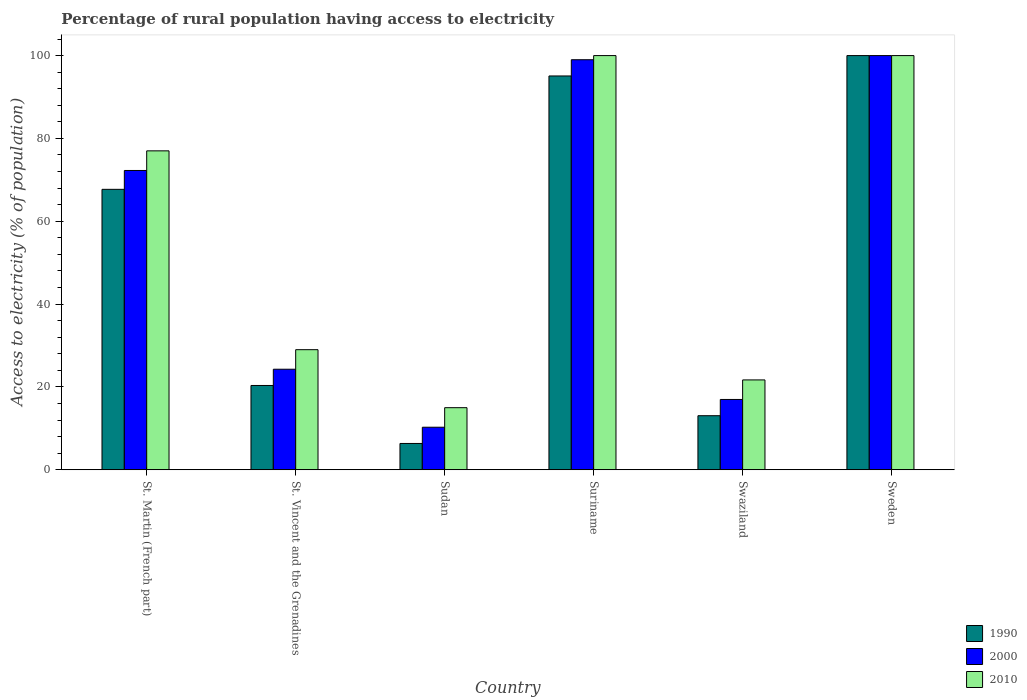Are the number of bars per tick equal to the number of legend labels?
Provide a succinct answer. Yes. Are the number of bars on each tick of the X-axis equal?
Offer a very short reply. Yes. How many bars are there on the 3rd tick from the right?
Ensure brevity in your answer.  3. What is the label of the 3rd group of bars from the left?
Keep it short and to the point. Sudan. In how many cases, is the number of bars for a given country not equal to the number of legend labels?
Keep it short and to the point. 0. What is the percentage of rural population having access to electricity in 1990 in Sudan?
Provide a short and direct response. 6.36. Across all countries, what is the maximum percentage of rural population having access to electricity in 2010?
Provide a succinct answer. 100. Across all countries, what is the minimum percentage of rural population having access to electricity in 2010?
Provide a short and direct response. 15. In which country was the percentage of rural population having access to electricity in 2010 maximum?
Your answer should be very brief. Suriname. In which country was the percentage of rural population having access to electricity in 2000 minimum?
Provide a short and direct response. Sudan. What is the total percentage of rural population having access to electricity in 2010 in the graph?
Provide a short and direct response. 342.7. What is the difference between the percentage of rural population having access to electricity in 1990 in St. Martin (French part) and that in St. Vincent and the Grenadines?
Offer a terse response. 47.35. What is the average percentage of rural population having access to electricity in 2000 per country?
Your answer should be compact. 53.8. What is the difference between the percentage of rural population having access to electricity of/in 1990 and percentage of rural population having access to electricity of/in 2010 in Suriname?
Give a very brief answer. -4.92. What is the ratio of the percentage of rural population having access to electricity in 2000 in St. Vincent and the Grenadines to that in Swaziland?
Your answer should be compact. 1.43. Is the percentage of rural population having access to electricity in 1990 in St. Vincent and the Grenadines less than that in Suriname?
Ensure brevity in your answer.  Yes. Is the difference between the percentage of rural population having access to electricity in 1990 in Suriname and Sweden greater than the difference between the percentage of rural population having access to electricity in 2010 in Suriname and Sweden?
Your response must be concise. No. What is the difference between the highest and the second highest percentage of rural population having access to electricity in 2010?
Provide a succinct answer. 23. What is the difference between the highest and the lowest percentage of rural population having access to electricity in 1990?
Give a very brief answer. 93.64. Is the sum of the percentage of rural population having access to electricity in 1990 in Sudan and Swaziland greater than the maximum percentage of rural population having access to electricity in 2000 across all countries?
Ensure brevity in your answer.  No. What does the 3rd bar from the left in Swaziland represents?
Provide a short and direct response. 2010. What does the 3rd bar from the right in St. Vincent and the Grenadines represents?
Ensure brevity in your answer.  1990. Is it the case that in every country, the sum of the percentage of rural population having access to electricity in 2010 and percentage of rural population having access to electricity in 2000 is greater than the percentage of rural population having access to electricity in 1990?
Give a very brief answer. Yes. Are all the bars in the graph horizontal?
Provide a short and direct response. No. How many countries are there in the graph?
Provide a succinct answer. 6. Are the values on the major ticks of Y-axis written in scientific E-notation?
Offer a very short reply. No. Does the graph contain any zero values?
Give a very brief answer. No. Does the graph contain grids?
Provide a succinct answer. No. Where does the legend appear in the graph?
Provide a short and direct response. Bottom right. What is the title of the graph?
Ensure brevity in your answer.  Percentage of rural population having access to electricity. Does "1989" appear as one of the legend labels in the graph?
Offer a terse response. No. What is the label or title of the Y-axis?
Your answer should be compact. Access to electricity (% of population). What is the Access to electricity (% of population) of 1990 in St. Martin (French part)?
Provide a short and direct response. 67.71. What is the Access to electricity (% of population) in 2000 in St. Martin (French part)?
Offer a very short reply. 72.27. What is the Access to electricity (% of population) in 2010 in St. Martin (French part)?
Make the answer very short. 77. What is the Access to electricity (% of population) of 1990 in St. Vincent and the Grenadines?
Provide a succinct answer. 20.36. What is the Access to electricity (% of population) in 2000 in St. Vincent and the Grenadines?
Keep it short and to the point. 24.28. What is the Access to electricity (% of population) in 2010 in St. Vincent and the Grenadines?
Provide a short and direct response. 29. What is the Access to electricity (% of population) of 1990 in Sudan?
Offer a very short reply. 6.36. What is the Access to electricity (% of population) in 2000 in Sudan?
Give a very brief answer. 10.28. What is the Access to electricity (% of population) of 1990 in Suriname?
Give a very brief answer. 95.08. What is the Access to electricity (% of population) of 2000 in Suriname?
Your response must be concise. 99. What is the Access to electricity (% of population) in 2010 in Suriname?
Provide a succinct answer. 100. What is the Access to electricity (% of population) in 1990 in Swaziland?
Keep it short and to the point. 13.06. What is the Access to electricity (% of population) of 2000 in Swaziland?
Offer a very short reply. 16.98. What is the Access to electricity (% of population) of 2010 in Swaziland?
Provide a succinct answer. 21.7. What is the Access to electricity (% of population) of 1990 in Sweden?
Your answer should be very brief. 100. Across all countries, what is the minimum Access to electricity (% of population) of 1990?
Your answer should be very brief. 6.36. Across all countries, what is the minimum Access to electricity (% of population) in 2000?
Your response must be concise. 10.28. What is the total Access to electricity (% of population) of 1990 in the graph?
Offer a very short reply. 302.57. What is the total Access to electricity (% of population) of 2000 in the graph?
Make the answer very short. 322.81. What is the total Access to electricity (% of population) in 2010 in the graph?
Provide a short and direct response. 342.7. What is the difference between the Access to electricity (% of population) in 1990 in St. Martin (French part) and that in St. Vincent and the Grenadines?
Your answer should be compact. 47.35. What is the difference between the Access to electricity (% of population) of 2000 in St. Martin (French part) and that in St. Vincent and the Grenadines?
Provide a succinct answer. 47.98. What is the difference between the Access to electricity (% of population) in 2010 in St. Martin (French part) and that in St. Vincent and the Grenadines?
Offer a very short reply. 48. What is the difference between the Access to electricity (% of population) in 1990 in St. Martin (French part) and that in Sudan?
Your answer should be compact. 61.35. What is the difference between the Access to electricity (% of population) in 2000 in St. Martin (French part) and that in Sudan?
Offer a very short reply. 61.98. What is the difference between the Access to electricity (% of population) in 1990 in St. Martin (French part) and that in Suriname?
Offer a very short reply. -27.37. What is the difference between the Access to electricity (% of population) in 2000 in St. Martin (French part) and that in Suriname?
Make the answer very short. -26.73. What is the difference between the Access to electricity (% of population) of 2010 in St. Martin (French part) and that in Suriname?
Provide a short and direct response. -23. What is the difference between the Access to electricity (% of population) in 1990 in St. Martin (French part) and that in Swaziland?
Provide a short and direct response. 54.65. What is the difference between the Access to electricity (% of population) in 2000 in St. Martin (French part) and that in Swaziland?
Make the answer very short. 55.28. What is the difference between the Access to electricity (% of population) in 2010 in St. Martin (French part) and that in Swaziland?
Give a very brief answer. 55.3. What is the difference between the Access to electricity (% of population) in 1990 in St. Martin (French part) and that in Sweden?
Make the answer very short. -32.29. What is the difference between the Access to electricity (% of population) in 2000 in St. Martin (French part) and that in Sweden?
Offer a very short reply. -27.73. What is the difference between the Access to electricity (% of population) of 2000 in St. Vincent and the Grenadines and that in Sudan?
Your answer should be very brief. 14. What is the difference between the Access to electricity (% of population) of 2010 in St. Vincent and the Grenadines and that in Sudan?
Keep it short and to the point. 14. What is the difference between the Access to electricity (% of population) in 1990 in St. Vincent and the Grenadines and that in Suriname?
Make the answer very short. -74.72. What is the difference between the Access to electricity (% of population) in 2000 in St. Vincent and the Grenadines and that in Suriname?
Provide a short and direct response. -74.72. What is the difference between the Access to electricity (% of population) in 2010 in St. Vincent and the Grenadines and that in Suriname?
Provide a short and direct response. -71. What is the difference between the Access to electricity (% of population) of 1990 in St. Vincent and the Grenadines and that in Swaziland?
Provide a short and direct response. 7.3. What is the difference between the Access to electricity (% of population) of 2000 in St. Vincent and the Grenadines and that in Swaziland?
Provide a short and direct response. 7.3. What is the difference between the Access to electricity (% of population) of 2010 in St. Vincent and the Grenadines and that in Swaziland?
Your answer should be very brief. 7.3. What is the difference between the Access to electricity (% of population) in 1990 in St. Vincent and the Grenadines and that in Sweden?
Your answer should be very brief. -79.64. What is the difference between the Access to electricity (% of population) of 2000 in St. Vincent and the Grenadines and that in Sweden?
Your response must be concise. -75.72. What is the difference between the Access to electricity (% of population) in 2010 in St. Vincent and the Grenadines and that in Sweden?
Make the answer very short. -71. What is the difference between the Access to electricity (% of population) of 1990 in Sudan and that in Suriname?
Make the answer very short. -88.72. What is the difference between the Access to electricity (% of population) in 2000 in Sudan and that in Suriname?
Provide a short and direct response. -88.72. What is the difference between the Access to electricity (% of population) of 2010 in Sudan and that in Suriname?
Your answer should be compact. -85. What is the difference between the Access to electricity (% of population) in 1990 in Sudan and that in Swaziland?
Ensure brevity in your answer.  -6.7. What is the difference between the Access to electricity (% of population) in 1990 in Sudan and that in Sweden?
Your answer should be very brief. -93.64. What is the difference between the Access to electricity (% of population) in 2000 in Sudan and that in Sweden?
Offer a very short reply. -89.72. What is the difference between the Access to electricity (% of population) in 2010 in Sudan and that in Sweden?
Make the answer very short. -85. What is the difference between the Access to electricity (% of population) in 1990 in Suriname and that in Swaziland?
Offer a terse response. 82.02. What is the difference between the Access to electricity (% of population) in 2000 in Suriname and that in Swaziland?
Give a very brief answer. 82.02. What is the difference between the Access to electricity (% of population) in 2010 in Suriname and that in Swaziland?
Offer a terse response. 78.3. What is the difference between the Access to electricity (% of population) of 1990 in Suriname and that in Sweden?
Make the answer very short. -4.92. What is the difference between the Access to electricity (% of population) of 1990 in Swaziland and that in Sweden?
Your answer should be very brief. -86.94. What is the difference between the Access to electricity (% of population) in 2000 in Swaziland and that in Sweden?
Provide a short and direct response. -83.02. What is the difference between the Access to electricity (% of population) of 2010 in Swaziland and that in Sweden?
Make the answer very short. -78.3. What is the difference between the Access to electricity (% of population) of 1990 in St. Martin (French part) and the Access to electricity (% of population) of 2000 in St. Vincent and the Grenadines?
Offer a very short reply. 43.43. What is the difference between the Access to electricity (% of population) of 1990 in St. Martin (French part) and the Access to electricity (% of population) of 2010 in St. Vincent and the Grenadines?
Keep it short and to the point. 38.71. What is the difference between the Access to electricity (% of population) of 2000 in St. Martin (French part) and the Access to electricity (% of population) of 2010 in St. Vincent and the Grenadines?
Your answer should be very brief. 43.27. What is the difference between the Access to electricity (% of population) of 1990 in St. Martin (French part) and the Access to electricity (% of population) of 2000 in Sudan?
Your answer should be very brief. 57.43. What is the difference between the Access to electricity (% of population) in 1990 in St. Martin (French part) and the Access to electricity (% of population) in 2010 in Sudan?
Keep it short and to the point. 52.71. What is the difference between the Access to electricity (% of population) in 2000 in St. Martin (French part) and the Access to electricity (% of population) in 2010 in Sudan?
Make the answer very short. 57.27. What is the difference between the Access to electricity (% of population) of 1990 in St. Martin (French part) and the Access to electricity (% of population) of 2000 in Suriname?
Provide a succinct answer. -31.29. What is the difference between the Access to electricity (% of population) in 1990 in St. Martin (French part) and the Access to electricity (% of population) in 2010 in Suriname?
Provide a short and direct response. -32.29. What is the difference between the Access to electricity (% of population) of 2000 in St. Martin (French part) and the Access to electricity (% of population) of 2010 in Suriname?
Your answer should be very brief. -27.73. What is the difference between the Access to electricity (% of population) of 1990 in St. Martin (French part) and the Access to electricity (% of population) of 2000 in Swaziland?
Make the answer very short. 50.73. What is the difference between the Access to electricity (% of population) in 1990 in St. Martin (French part) and the Access to electricity (% of population) in 2010 in Swaziland?
Provide a succinct answer. 46.01. What is the difference between the Access to electricity (% of population) of 2000 in St. Martin (French part) and the Access to electricity (% of population) of 2010 in Swaziland?
Your answer should be very brief. 50.56. What is the difference between the Access to electricity (% of population) of 1990 in St. Martin (French part) and the Access to electricity (% of population) of 2000 in Sweden?
Provide a succinct answer. -32.29. What is the difference between the Access to electricity (% of population) in 1990 in St. Martin (French part) and the Access to electricity (% of population) in 2010 in Sweden?
Provide a succinct answer. -32.29. What is the difference between the Access to electricity (% of population) in 2000 in St. Martin (French part) and the Access to electricity (% of population) in 2010 in Sweden?
Your answer should be very brief. -27.73. What is the difference between the Access to electricity (% of population) of 1990 in St. Vincent and the Grenadines and the Access to electricity (% of population) of 2000 in Sudan?
Provide a succinct answer. 10.08. What is the difference between the Access to electricity (% of population) of 1990 in St. Vincent and the Grenadines and the Access to electricity (% of population) of 2010 in Sudan?
Give a very brief answer. 5.36. What is the difference between the Access to electricity (% of population) in 2000 in St. Vincent and the Grenadines and the Access to electricity (% of population) in 2010 in Sudan?
Your answer should be very brief. 9.28. What is the difference between the Access to electricity (% of population) in 1990 in St. Vincent and the Grenadines and the Access to electricity (% of population) in 2000 in Suriname?
Give a very brief answer. -78.64. What is the difference between the Access to electricity (% of population) in 1990 in St. Vincent and the Grenadines and the Access to electricity (% of population) in 2010 in Suriname?
Offer a terse response. -79.64. What is the difference between the Access to electricity (% of population) in 2000 in St. Vincent and the Grenadines and the Access to electricity (% of population) in 2010 in Suriname?
Offer a very short reply. -75.72. What is the difference between the Access to electricity (% of population) in 1990 in St. Vincent and the Grenadines and the Access to electricity (% of population) in 2000 in Swaziland?
Make the answer very short. 3.38. What is the difference between the Access to electricity (% of population) in 1990 in St. Vincent and the Grenadines and the Access to electricity (% of population) in 2010 in Swaziland?
Your answer should be compact. -1.34. What is the difference between the Access to electricity (% of population) of 2000 in St. Vincent and the Grenadines and the Access to electricity (% of population) of 2010 in Swaziland?
Your answer should be very brief. 2.58. What is the difference between the Access to electricity (% of population) of 1990 in St. Vincent and the Grenadines and the Access to electricity (% of population) of 2000 in Sweden?
Ensure brevity in your answer.  -79.64. What is the difference between the Access to electricity (% of population) of 1990 in St. Vincent and the Grenadines and the Access to electricity (% of population) of 2010 in Sweden?
Keep it short and to the point. -79.64. What is the difference between the Access to electricity (% of population) in 2000 in St. Vincent and the Grenadines and the Access to electricity (% of population) in 2010 in Sweden?
Keep it short and to the point. -75.72. What is the difference between the Access to electricity (% of population) in 1990 in Sudan and the Access to electricity (% of population) in 2000 in Suriname?
Offer a terse response. -92.64. What is the difference between the Access to electricity (% of population) of 1990 in Sudan and the Access to electricity (% of population) of 2010 in Suriname?
Keep it short and to the point. -93.64. What is the difference between the Access to electricity (% of population) in 2000 in Sudan and the Access to electricity (% of population) in 2010 in Suriname?
Provide a short and direct response. -89.72. What is the difference between the Access to electricity (% of population) in 1990 in Sudan and the Access to electricity (% of population) in 2000 in Swaziland?
Your answer should be very brief. -10.62. What is the difference between the Access to electricity (% of population) in 1990 in Sudan and the Access to electricity (% of population) in 2010 in Swaziland?
Provide a succinct answer. -15.34. What is the difference between the Access to electricity (% of population) of 2000 in Sudan and the Access to electricity (% of population) of 2010 in Swaziland?
Keep it short and to the point. -11.42. What is the difference between the Access to electricity (% of population) of 1990 in Sudan and the Access to electricity (% of population) of 2000 in Sweden?
Your response must be concise. -93.64. What is the difference between the Access to electricity (% of population) of 1990 in Sudan and the Access to electricity (% of population) of 2010 in Sweden?
Your response must be concise. -93.64. What is the difference between the Access to electricity (% of population) of 2000 in Sudan and the Access to electricity (% of population) of 2010 in Sweden?
Your response must be concise. -89.72. What is the difference between the Access to electricity (% of population) in 1990 in Suriname and the Access to electricity (% of population) in 2000 in Swaziland?
Give a very brief answer. 78.1. What is the difference between the Access to electricity (% of population) of 1990 in Suriname and the Access to electricity (% of population) of 2010 in Swaziland?
Make the answer very short. 73.38. What is the difference between the Access to electricity (% of population) in 2000 in Suriname and the Access to electricity (% of population) in 2010 in Swaziland?
Make the answer very short. 77.3. What is the difference between the Access to electricity (% of population) of 1990 in Suriname and the Access to electricity (% of population) of 2000 in Sweden?
Your response must be concise. -4.92. What is the difference between the Access to electricity (% of population) of 1990 in Suriname and the Access to electricity (% of population) of 2010 in Sweden?
Your response must be concise. -4.92. What is the difference between the Access to electricity (% of population) of 2000 in Suriname and the Access to electricity (% of population) of 2010 in Sweden?
Offer a terse response. -1. What is the difference between the Access to electricity (% of population) of 1990 in Swaziland and the Access to electricity (% of population) of 2000 in Sweden?
Provide a short and direct response. -86.94. What is the difference between the Access to electricity (% of population) of 1990 in Swaziland and the Access to electricity (% of population) of 2010 in Sweden?
Keep it short and to the point. -86.94. What is the difference between the Access to electricity (% of population) in 2000 in Swaziland and the Access to electricity (% of population) in 2010 in Sweden?
Ensure brevity in your answer.  -83.02. What is the average Access to electricity (% of population) of 1990 per country?
Give a very brief answer. 50.43. What is the average Access to electricity (% of population) in 2000 per country?
Give a very brief answer. 53.8. What is the average Access to electricity (% of population) in 2010 per country?
Your response must be concise. 57.12. What is the difference between the Access to electricity (% of population) of 1990 and Access to electricity (% of population) of 2000 in St. Martin (French part)?
Your answer should be compact. -4.55. What is the difference between the Access to electricity (% of population) of 1990 and Access to electricity (% of population) of 2010 in St. Martin (French part)?
Give a very brief answer. -9.29. What is the difference between the Access to electricity (% of population) of 2000 and Access to electricity (% of population) of 2010 in St. Martin (French part)?
Provide a short and direct response. -4.74. What is the difference between the Access to electricity (% of population) in 1990 and Access to electricity (% of population) in 2000 in St. Vincent and the Grenadines?
Ensure brevity in your answer.  -3.92. What is the difference between the Access to electricity (% of population) in 1990 and Access to electricity (% of population) in 2010 in St. Vincent and the Grenadines?
Offer a very short reply. -8.64. What is the difference between the Access to electricity (% of population) of 2000 and Access to electricity (% of population) of 2010 in St. Vincent and the Grenadines?
Offer a very short reply. -4.72. What is the difference between the Access to electricity (% of population) of 1990 and Access to electricity (% of population) of 2000 in Sudan?
Give a very brief answer. -3.92. What is the difference between the Access to electricity (% of population) in 1990 and Access to electricity (% of population) in 2010 in Sudan?
Give a very brief answer. -8.64. What is the difference between the Access to electricity (% of population) in 2000 and Access to electricity (% of population) in 2010 in Sudan?
Offer a terse response. -4.72. What is the difference between the Access to electricity (% of population) of 1990 and Access to electricity (% of population) of 2000 in Suriname?
Your answer should be compact. -3.92. What is the difference between the Access to electricity (% of population) in 1990 and Access to electricity (% of population) in 2010 in Suriname?
Give a very brief answer. -4.92. What is the difference between the Access to electricity (% of population) in 1990 and Access to electricity (% of population) in 2000 in Swaziland?
Ensure brevity in your answer.  -3.92. What is the difference between the Access to electricity (% of population) in 1990 and Access to electricity (% of population) in 2010 in Swaziland?
Offer a terse response. -8.64. What is the difference between the Access to electricity (% of population) of 2000 and Access to electricity (% of population) of 2010 in Swaziland?
Your response must be concise. -4.72. What is the difference between the Access to electricity (% of population) in 1990 and Access to electricity (% of population) in 2000 in Sweden?
Offer a very short reply. 0. What is the difference between the Access to electricity (% of population) in 1990 and Access to electricity (% of population) in 2010 in Sweden?
Make the answer very short. 0. What is the ratio of the Access to electricity (% of population) in 1990 in St. Martin (French part) to that in St. Vincent and the Grenadines?
Offer a terse response. 3.33. What is the ratio of the Access to electricity (% of population) of 2000 in St. Martin (French part) to that in St. Vincent and the Grenadines?
Make the answer very short. 2.98. What is the ratio of the Access to electricity (% of population) of 2010 in St. Martin (French part) to that in St. Vincent and the Grenadines?
Provide a short and direct response. 2.66. What is the ratio of the Access to electricity (% of population) in 1990 in St. Martin (French part) to that in Sudan?
Offer a very short reply. 10.65. What is the ratio of the Access to electricity (% of population) in 2000 in St. Martin (French part) to that in Sudan?
Make the answer very short. 7.03. What is the ratio of the Access to electricity (% of population) of 2010 in St. Martin (French part) to that in Sudan?
Offer a terse response. 5.13. What is the ratio of the Access to electricity (% of population) of 1990 in St. Martin (French part) to that in Suriname?
Your answer should be very brief. 0.71. What is the ratio of the Access to electricity (% of population) in 2000 in St. Martin (French part) to that in Suriname?
Offer a terse response. 0.73. What is the ratio of the Access to electricity (% of population) in 2010 in St. Martin (French part) to that in Suriname?
Offer a terse response. 0.77. What is the ratio of the Access to electricity (% of population) in 1990 in St. Martin (French part) to that in Swaziland?
Your answer should be very brief. 5.18. What is the ratio of the Access to electricity (% of population) of 2000 in St. Martin (French part) to that in Swaziland?
Make the answer very short. 4.26. What is the ratio of the Access to electricity (% of population) of 2010 in St. Martin (French part) to that in Swaziland?
Ensure brevity in your answer.  3.55. What is the ratio of the Access to electricity (% of population) in 1990 in St. Martin (French part) to that in Sweden?
Offer a terse response. 0.68. What is the ratio of the Access to electricity (% of population) in 2000 in St. Martin (French part) to that in Sweden?
Your answer should be very brief. 0.72. What is the ratio of the Access to electricity (% of population) in 2010 in St. Martin (French part) to that in Sweden?
Provide a short and direct response. 0.77. What is the ratio of the Access to electricity (% of population) of 1990 in St. Vincent and the Grenadines to that in Sudan?
Ensure brevity in your answer.  3.2. What is the ratio of the Access to electricity (% of population) of 2000 in St. Vincent and the Grenadines to that in Sudan?
Your response must be concise. 2.36. What is the ratio of the Access to electricity (% of population) of 2010 in St. Vincent and the Grenadines to that in Sudan?
Give a very brief answer. 1.93. What is the ratio of the Access to electricity (% of population) in 1990 in St. Vincent and the Grenadines to that in Suriname?
Offer a very short reply. 0.21. What is the ratio of the Access to electricity (% of population) of 2000 in St. Vincent and the Grenadines to that in Suriname?
Offer a terse response. 0.25. What is the ratio of the Access to electricity (% of population) in 2010 in St. Vincent and the Grenadines to that in Suriname?
Your answer should be very brief. 0.29. What is the ratio of the Access to electricity (% of population) in 1990 in St. Vincent and the Grenadines to that in Swaziland?
Provide a short and direct response. 1.56. What is the ratio of the Access to electricity (% of population) of 2000 in St. Vincent and the Grenadines to that in Swaziland?
Ensure brevity in your answer.  1.43. What is the ratio of the Access to electricity (% of population) of 2010 in St. Vincent and the Grenadines to that in Swaziland?
Provide a succinct answer. 1.34. What is the ratio of the Access to electricity (% of population) in 1990 in St. Vincent and the Grenadines to that in Sweden?
Keep it short and to the point. 0.2. What is the ratio of the Access to electricity (% of population) of 2000 in St. Vincent and the Grenadines to that in Sweden?
Your answer should be compact. 0.24. What is the ratio of the Access to electricity (% of population) in 2010 in St. Vincent and the Grenadines to that in Sweden?
Your answer should be very brief. 0.29. What is the ratio of the Access to electricity (% of population) of 1990 in Sudan to that in Suriname?
Offer a very short reply. 0.07. What is the ratio of the Access to electricity (% of population) of 2000 in Sudan to that in Suriname?
Offer a very short reply. 0.1. What is the ratio of the Access to electricity (% of population) of 1990 in Sudan to that in Swaziland?
Your answer should be very brief. 0.49. What is the ratio of the Access to electricity (% of population) in 2000 in Sudan to that in Swaziland?
Provide a short and direct response. 0.61. What is the ratio of the Access to electricity (% of population) of 2010 in Sudan to that in Swaziland?
Make the answer very short. 0.69. What is the ratio of the Access to electricity (% of population) of 1990 in Sudan to that in Sweden?
Provide a succinct answer. 0.06. What is the ratio of the Access to electricity (% of population) of 2000 in Sudan to that in Sweden?
Provide a short and direct response. 0.1. What is the ratio of the Access to electricity (% of population) in 2010 in Sudan to that in Sweden?
Your answer should be compact. 0.15. What is the ratio of the Access to electricity (% of population) in 1990 in Suriname to that in Swaziland?
Provide a short and direct response. 7.28. What is the ratio of the Access to electricity (% of population) of 2000 in Suriname to that in Swaziland?
Ensure brevity in your answer.  5.83. What is the ratio of the Access to electricity (% of population) of 2010 in Suriname to that in Swaziland?
Make the answer very short. 4.61. What is the ratio of the Access to electricity (% of population) of 1990 in Suriname to that in Sweden?
Offer a terse response. 0.95. What is the ratio of the Access to electricity (% of population) in 2000 in Suriname to that in Sweden?
Offer a very short reply. 0.99. What is the ratio of the Access to electricity (% of population) of 1990 in Swaziland to that in Sweden?
Offer a very short reply. 0.13. What is the ratio of the Access to electricity (% of population) of 2000 in Swaziland to that in Sweden?
Your answer should be compact. 0.17. What is the ratio of the Access to electricity (% of population) in 2010 in Swaziland to that in Sweden?
Your response must be concise. 0.22. What is the difference between the highest and the second highest Access to electricity (% of population) of 1990?
Offer a terse response. 4.92. What is the difference between the highest and the lowest Access to electricity (% of population) in 1990?
Provide a succinct answer. 93.64. What is the difference between the highest and the lowest Access to electricity (% of population) in 2000?
Your response must be concise. 89.72. 